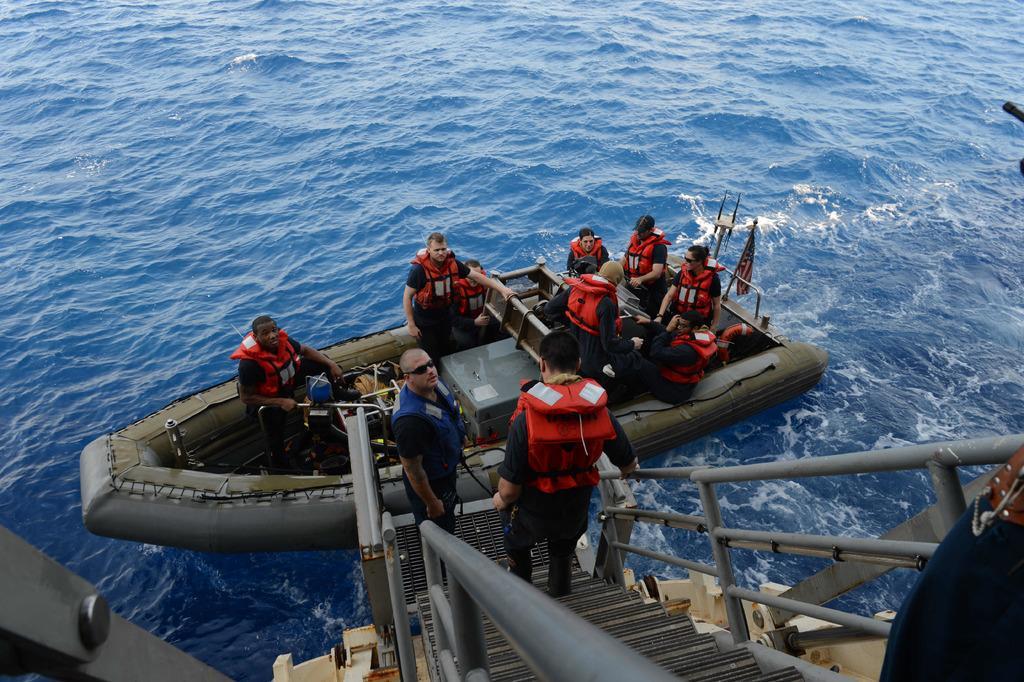Could you give a brief overview of what you see in this image? In this image I can see a group of people in the boat, three persons on the steps, metal rods and water. This image is taken may be in the ocean. 